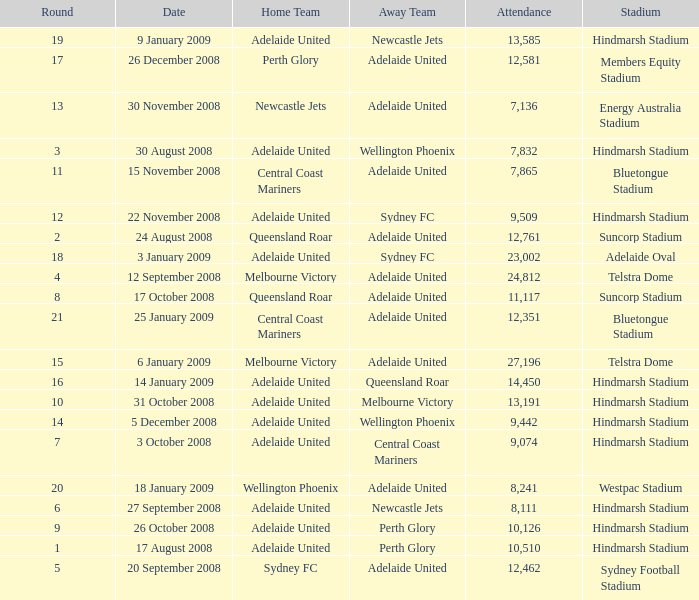What is the round when 11,117 people attended the game on 26 October 2008? 9.0. 